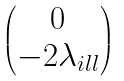Convert formula to latex. <formula><loc_0><loc_0><loc_500><loc_500>\begin{pmatrix} 0 \\ - 2 \lambda _ { i l l } \end{pmatrix}</formula> 